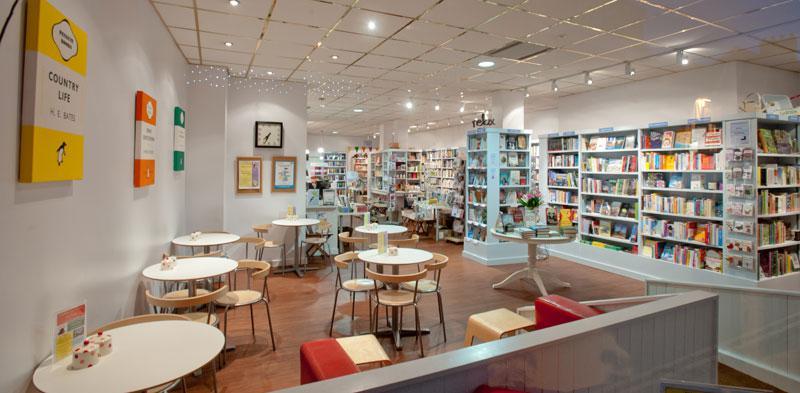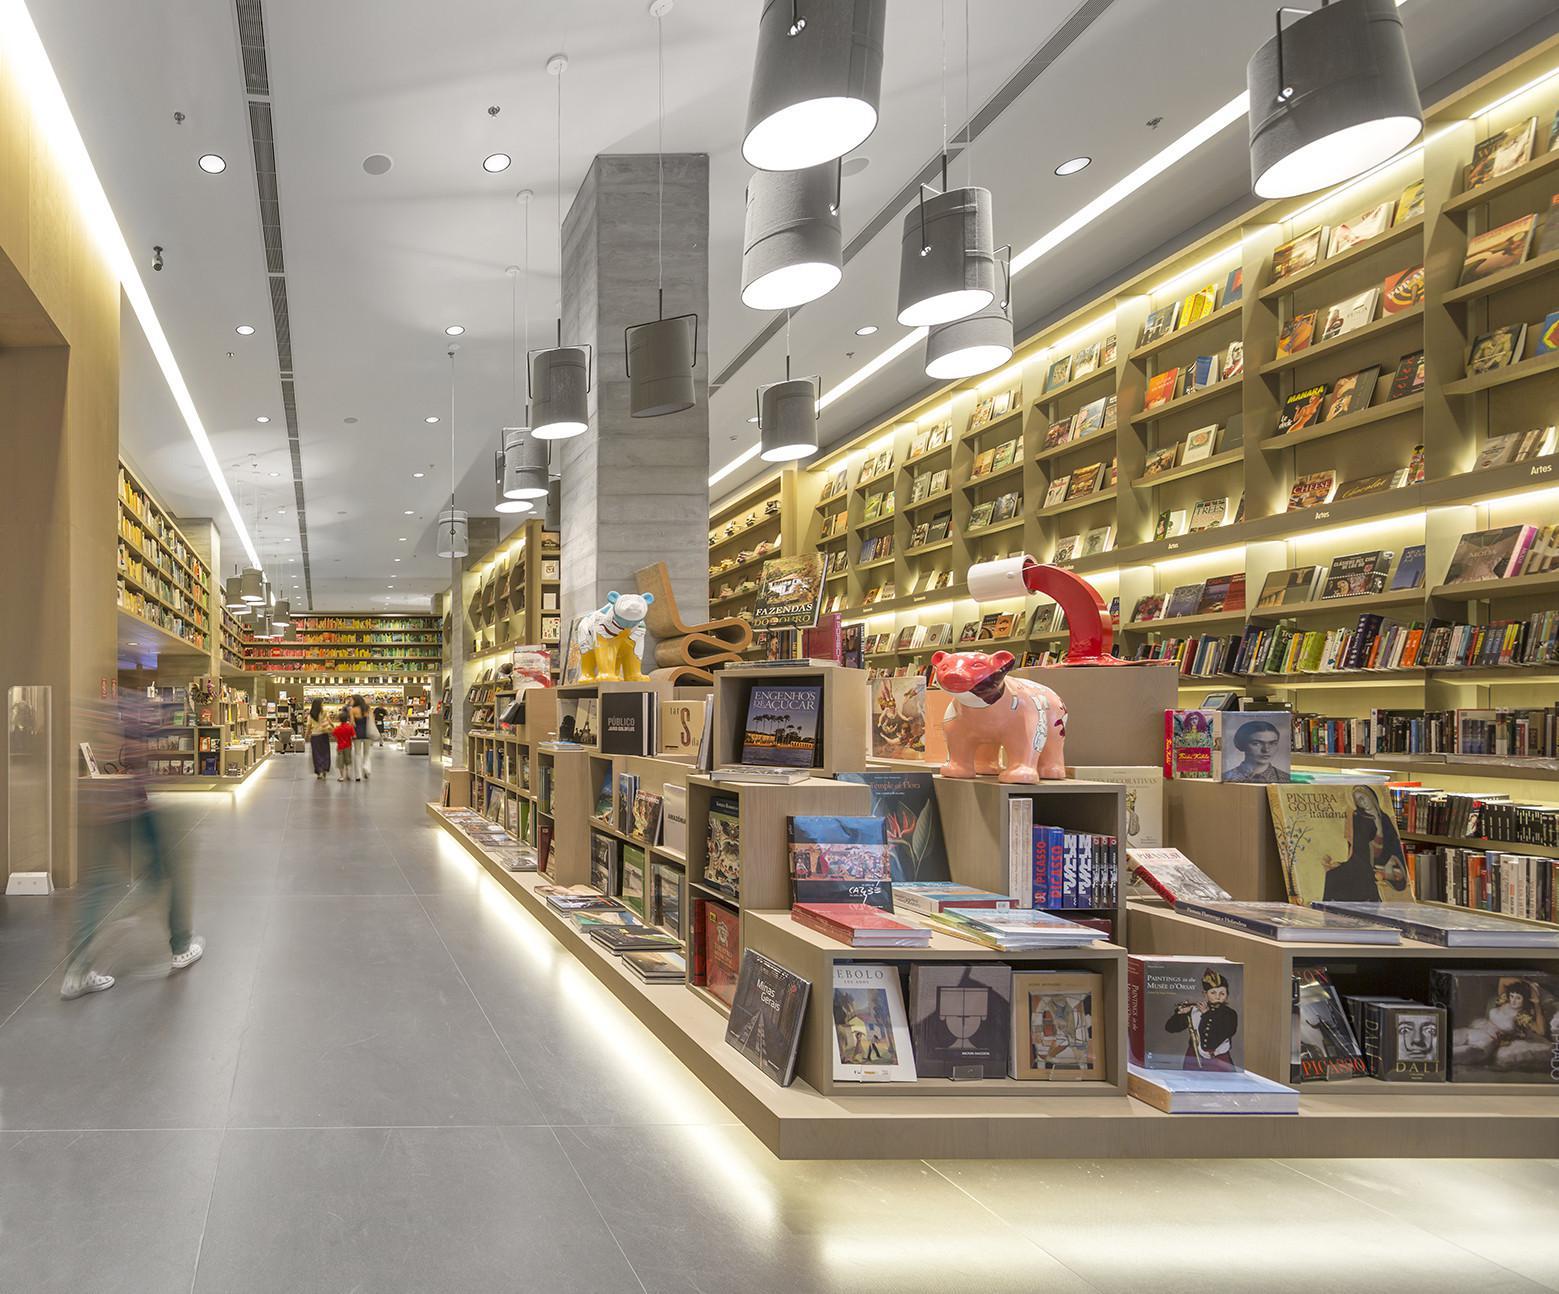The first image is the image on the left, the second image is the image on the right. Analyze the images presented: Is the assertion "In one of the images there is a bookstore without any shoppers." valid? Answer yes or no. Yes. The first image is the image on the left, the second image is the image on the right. For the images shown, is this caption "In one image, four rows of books are on shelves high over the heads of people on the floor below." true? Answer yes or no. Yes. 